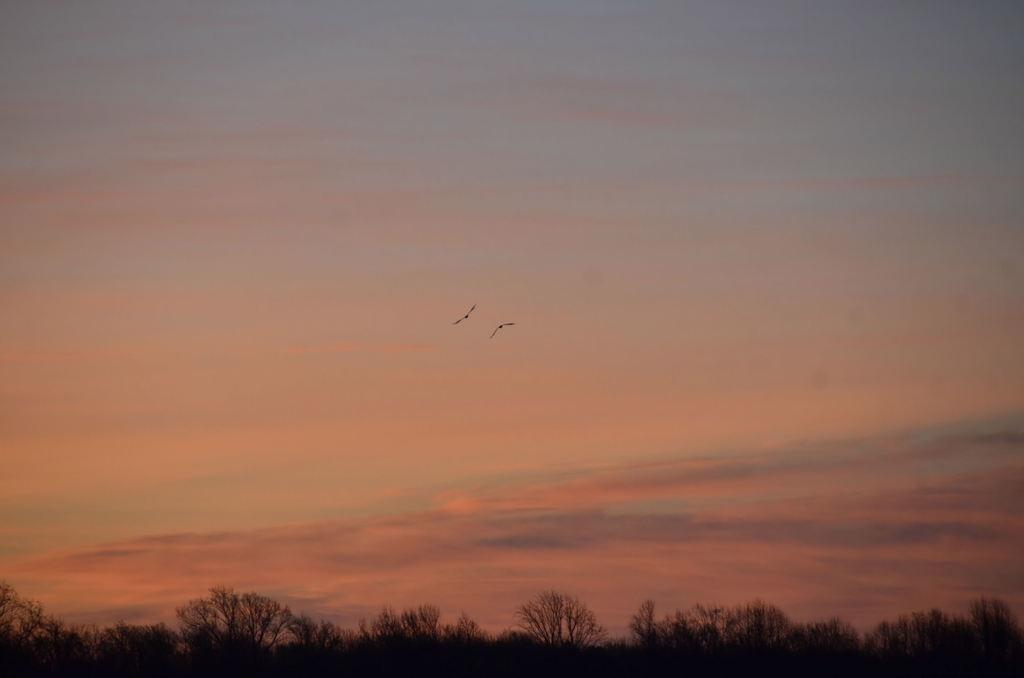Can you describe this image briefly? In the picture there are two birds flying in the sky and on the ground there are many trees. 